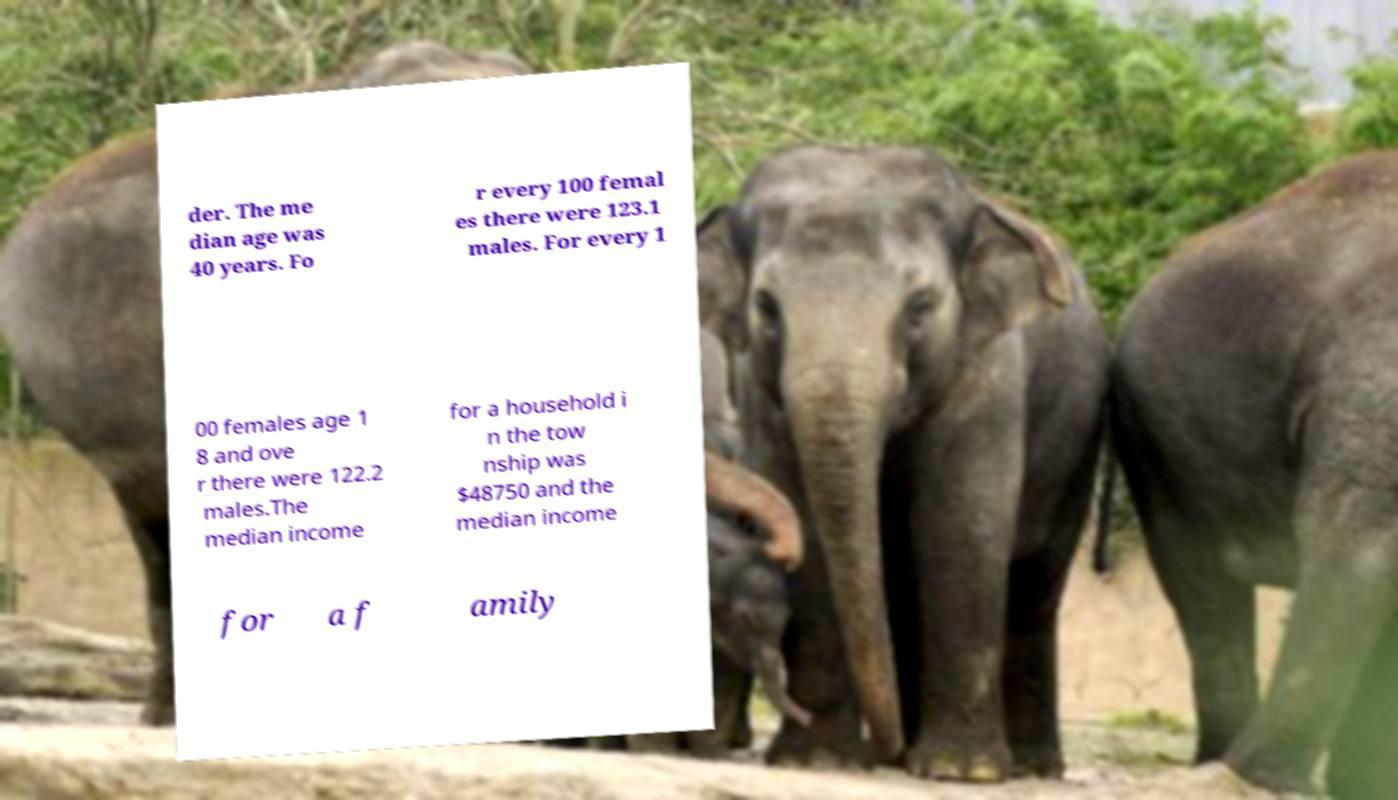Could you extract and type out the text from this image? der. The me dian age was 40 years. Fo r every 100 femal es there were 123.1 males. For every 1 00 females age 1 8 and ove r there were 122.2 males.The median income for a household i n the tow nship was $48750 and the median income for a f amily 